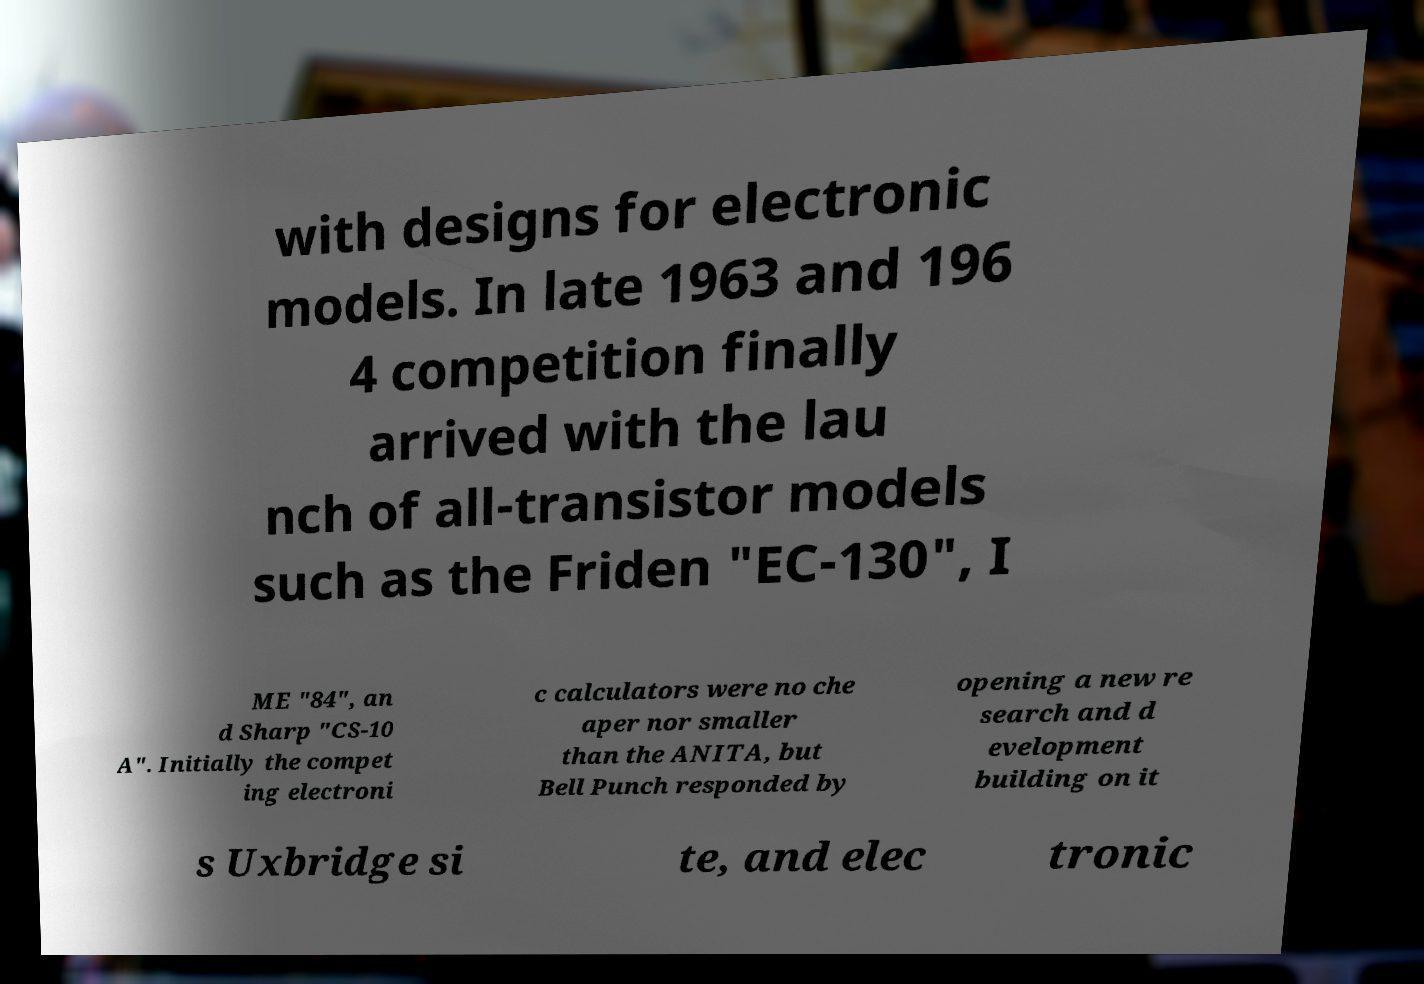Can you accurately transcribe the text from the provided image for me? with designs for electronic models. In late 1963 and 196 4 competition finally arrived with the lau nch of all-transistor models such as the Friden "EC-130", I ME "84", an d Sharp "CS-10 A". Initially the compet ing electroni c calculators were no che aper nor smaller than the ANITA, but Bell Punch responded by opening a new re search and d evelopment building on it s Uxbridge si te, and elec tronic 